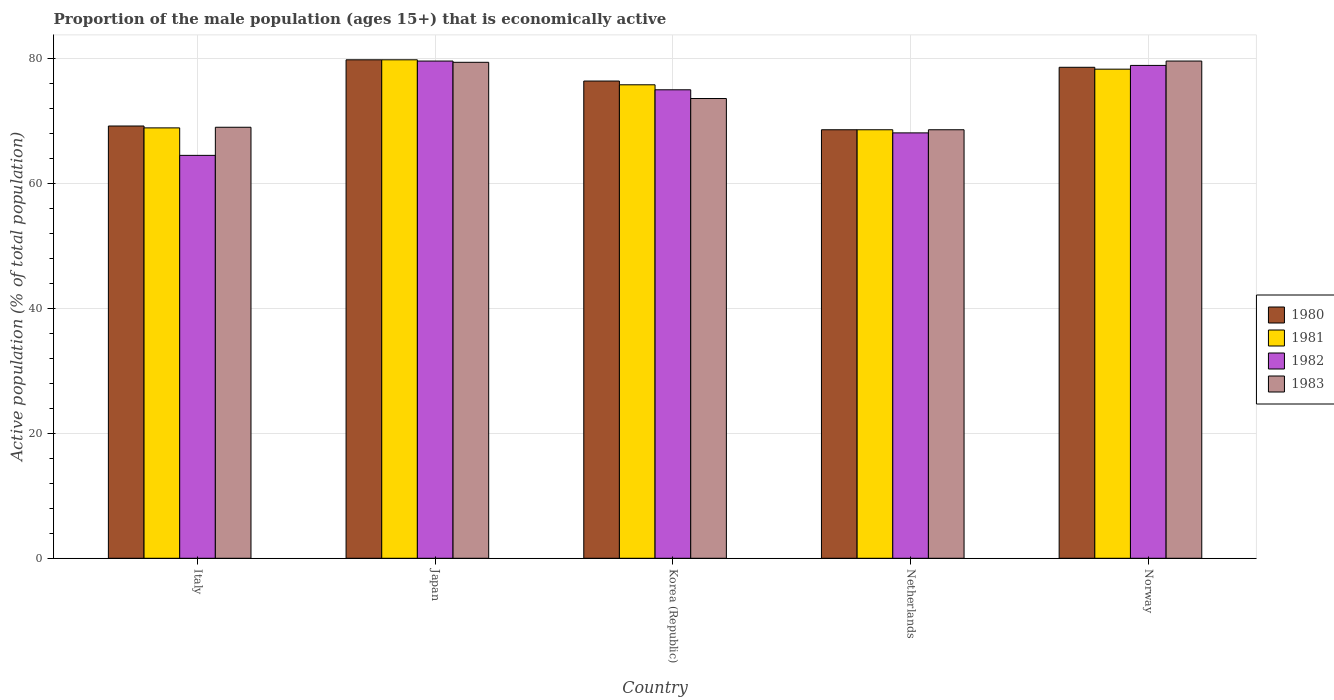Are the number of bars per tick equal to the number of legend labels?
Give a very brief answer. Yes. Are the number of bars on each tick of the X-axis equal?
Provide a succinct answer. Yes. How many bars are there on the 5th tick from the right?
Your answer should be very brief. 4. What is the label of the 5th group of bars from the left?
Give a very brief answer. Norway. In how many cases, is the number of bars for a given country not equal to the number of legend labels?
Provide a short and direct response. 0. What is the proportion of the male population that is economically active in 1981 in Norway?
Offer a terse response. 78.3. Across all countries, what is the maximum proportion of the male population that is economically active in 1983?
Your answer should be compact. 79.6. Across all countries, what is the minimum proportion of the male population that is economically active in 1982?
Keep it short and to the point. 64.5. What is the total proportion of the male population that is economically active in 1983 in the graph?
Ensure brevity in your answer.  370.2. What is the difference between the proportion of the male population that is economically active in 1982 in Italy and that in Norway?
Offer a terse response. -14.4. What is the difference between the proportion of the male population that is economically active in 1983 in Italy and the proportion of the male population that is economically active in 1981 in Japan?
Offer a terse response. -10.8. What is the average proportion of the male population that is economically active in 1983 per country?
Offer a terse response. 74.04. What is the difference between the proportion of the male population that is economically active of/in 1982 and proportion of the male population that is economically active of/in 1980 in Norway?
Offer a terse response. 0.3. What is the ratio of the proportion of the male population that is economically active in 1981 in Italy to that in Netherlands?
Your answer should be very brief. 1. What is the difference between the highest and the second highest proportion of the male population that is economically active in 1981?
Offer a very short reply. -2.5. What is the difference between the highest and the lowest proportion of the male population that is economically active in 1980?
Your answer should be compact. 11.2. In how many countries, is the proportion of the male population that is economically active in 1982 greater than the average proportion of the male population that is economically active in 1982 taken over all countries?
Give a very brief answer. 3. Is the sum of the proportion of the male population that is economically active in 1980 in Japan and Netherlands greater than the maximum proportion of the male population that is economically active in 1982 across all countries?
Make the answer very short. Yes. Is it the case that in every country, the sum of the proportion of the male population that is economically active in 1983 and proportion of the male population that is economically active in 1981 is greater than the sum of proportion of the male population that is economically active in 1982 and proportion of the male population that is economically active in 1980?
Make the answer very short. No. What does the 2nd bar from the right in Japan represents?
Your answer should be compact. 1982. Is it the case that in every country, the sum of the proportion of the male population that is economically active in 1982 and proportion of the male population that is economically active in 1983 is greater than the proportion of the male population that is economically active in 1980?
Keep it short and to the point. Yes. How many bars are there?
Provide a succinct answer. 20. Are all the bars in the graph horizontal?
Provide a succinct answer. No. How many countries are there in the graph?
Keep it short and to the point. 5. How many legend labels are there?
Your answer should be compact. 4. How are the legend labels stacked?
Give a very brief answer. Vertical. What is the title of the graph?
Offer a very short reply. Proportion of the male population (ages 15+) that is economically active. What is the label or title of the X-axis?
Ensure brevity in your answer.  Country. What is the label or title of the Y-axis?
Your answer should be compact. Active population (% of total population). What is the Active population (% of total population) in 1980 in Italy?
Your response must be concise. 69.2. What is the Active population (% of total population) of 1981 in Italy?
Offer a very short reply. 68.9. What is the Active population (% of total population) in 1982 in Italy?
Keep it short and to the point. 64.5. What is the Active population (% of total population) of 1980 in Japan?
Make the answer very short. 79.8. What is the Active population (% of total population) of 1981 in Japan?
Provide a short and direct response. 79.8. What is the Active population (% of total population) of 1982 in Japan?
Make the answer very short. 79.6. What is the Active population (% of total population) of 1983 in Japan?
Ensure brevity in your answer.  79.4. What is the Active population (% of total population) in 1980 in Korea (Republic)?
Make the answer very short. 76.4. What is the Active population (% of total population) in 1981 in Korea (Republic)?
Provide a short and direct response. 75.8. What is the Active population (% of total population) in 1983 in Korea (Republic)?
Give a very brief answer. 73.6. What is the Active population (% of total population) in 1980 in Netherlands?
Give a very brief answer. 68.6. What is the Active population (% of total population) in 1981 in Netherlands?
Your answer should be compact. 68.6. What is the Active population (% of total population) in 1982 in Netherlands?
Offer a terse response. 68.1. What is the Active population (% of total population) of 1983 in Netherlands?
Give a very brief answer. 68.6. What is the Active population (% of total population) of 1980 in Norway?
Ensure brevity in your answer.  78.6. What is the Active population (% of total population) of 1981 in Norway?
Make the answer very short. 78.3. What is the Active population (% of total population) in 1982 in Norway?
Offer a terse response. 78.9. What is the Active population (% of total population) of 1983 in Norway?
Make the answer very short. 79.6. Across all countries, what is the maximum Active population (% of total population) in 1980?
Provide a short and direct response. 79.8. Across all countries, what is the maximum Active population (% of total population) of 1981?
Give a very brief answer. 79.8. Across all countries, what is the maximum Active population (% of total population) of 1982?
Provide a short and direct response. 79.6. Across all countries, what is the maximum Active population (% of total population) of 1983?
Your answer should be very brief. 79.6. Across all countries, what is the minimum Active population (% of total population) in 1980?
Make the answer very short. 68.6. Across all countries, what is the minimum Active population (% of total population) of 1981?
Ensure brevity in your answer.  68.6. Across all countries, what is the minimum Active population (% of total population) in 1982?
Make the answer very short. 64.5. Across all countries, what is the minimum Active population (% of total population) of 1983?
Offer a very short reply. 68.6. What is the total Active population (% of total population) in 1980 in the graph?
Your answer should be very brief. 372.6. What is the total Active population (% of total population) in 1981 in the graph?
Keep it short and to the point. 371.4. What is the total Active population (% of total population) of 1982 in the graph?
Offer a very short reply. 366.1. What is the total Active population (% of total population) of 1983 in the graph?
Make the answer very short. 370.2. What is the difference between the Active population (% of total population) of 1980 in Italy and that in Japan?
Provide a short and direct response. -10.6. What is the difference between the Active population (% of total population) in 1982 in Italy and that in Japan?
Provide a short and direct response. -15.1. What is the difference between the Active population (% of total population) in 1983 in Italy and that in Japan?
Ensure brevity in your answer.  -10.4. What is the difference between the Active population (% of total population) of 1981 in Italy and that in Korea (Republic)?
Your response must be concise. -6.9. What is the difference between the Active population (% of total population) of 1982 in Italy and that in Korea (Republic)?
Your response must be concise. -10.5. What is the difference between the Active population (% of total population) in 1983 in Italy and that in Korea (Republic)?
Offer a very short reply. -4.6. What is the difference between the Active population (% of total population) in 1981 in Italy and that in Netherlands?
Provide a succinct answer. 0.3. What is the difference between the Active population (% of total population) in 1982 in Italy and that in Netherlands?
Your answer should be very brief. -3.6. What is the difference between the Active population (% of total population) of 1980 in Italy and that in Norway?
Your response must be concise. -9.4. What is the difference between the Active population (% of total population) of 1981 in Italy and that in Norway?
Keep it short and to the point. -9.4. What is the difference between the Active population (% of total population) in 1982 in Italy and that in Norway?
Give a very brief answer. -14.4. What is the difference between the Active population (% of total population) of 1983 in Italy and that in Norway?
Your answer should be compact. -10.6. What is the difference between the Active population (% of total population) of 1981 in Japan and that in Korea (Republic)?
Provide a short and direct response. 4. What is the difference between the Active population (% of total population) in 1983 in Japan and that in Korea (Republic)?
Offer a terse response. 5.8. What is the difference between the Active population (% of total population) in 1980 in Japan and that in Netherlands?
Give a very brief answer. 11.2. What is the difference between the Active population (% of total population) in 1982 in Japan and that in Netherlands?
Your response must be concise. 11.5. What is the difference between the Active population (% of total population) in 1981 in Korea (Republic) and that in Netherlands?
Ensure brevity in your answer.  7.2. What is the difference between the Active population (% of total population) in 1981 in Korea (Republic) and that in Norway?
Give a very brief answer. -2.5. What is the difference between the Active population (% of total population) in 1983 in Korea (Republic) and that in Norway?
Offer a very short reply. -6. What is the difference between the Active population (% of total population) in 1980 in Italy and the Active population (% of total population) in 1981 in Japan?
Provide a short and direct response. -10.6. What is the difference between the Active population (% of total population) in 1980 in Italy and the Active population (% of total population) in 1982 in Japan?
Provide a succinct answer. -10.4. What is the difference between the Active population (% of total population) of 1982 in Italy and the Active population (% of total population) of 1983 in Japan?
Keep it short and to the point. -14.9. What is the difference between the Active population (% of total population) in 1980 in Italy and the Active population (% of total population) in 1983 in Korea (Republic)?
Keep it short and to the point. -4.4. What is the difference between the Active population (% of total population) of 1981 in Italy and the Active population (% of total population) of 1983 in Korea (Republic)?
Offer a terse response. -4.7. What is the difference between the Active population (% of total population) of 1980 in Italy and the Active population (% of total population) of 1983 in Netherlands?
Your response must be concise. 0.6. What is the difference between the Active population (% of total population) of 1981 in Italy and the Active population (% of total population) of 1983 in Netherlands?
Provide a short and direct response. 0.3. What is the difference between the Active population (% of total population) of 1982 in Italy and the Active population (% of total population) of 1983 in Netherlands?
Provide a short and direct response. -4.1. What is the difference between the Active population (% of total population) of 1980 in Italy and the Active population (% of total population) of 1981 in Norway?
Provide a short and direct response. -9.1. What is the difference between the Active population (% of total population) in 1981 in Italy and the Active population (% of total population) in 1982 in Norway?
Provide a short and direct response. -10. What is the difference between the Active population (% of total population) of 1982 in Italy and the Active population (% of total population) of 1983 in Norway?
Offer a very short reply. -15.1. What is the difference between the Active population (% of total population) of 1980 in Japan and the Active population (% of total population) of 1981 in Korea (Republic)?
Provide a short and direct response. 4. What is the difference between the Active population (% of total population) of 1980 in Japan and the Active population (% of total population) of 1983 in Korea (Republic)?
Your response must be concise. 6.2. What is the difference between the Active population (% of total population) of 1981 in Japan and the Active population (% of total population) of 1983 in Korea (Republic)?
Give a very brief answer. 6.2. What is the difference between the Active population (% of total population) in 1982 in Japan and the Active population (% of total population) in 1983 in Korea (Republic)?
Make the answer very short. 6. What is the difference between the Active population (% of total population) of 1980 in Japan and the Active population (% of total population) of 1981 in Netherlands?
Keep it short and to the point. 11.2. What is the difference between the Active population (% of total population) in 1980 in Japan and the Active population (% of total population) in 1982 in Netherlands?
Your answer should be very brief. 11.7. What is the difference between the Active population (% of total population) in 1980 in Japan and the Active population (% of total population) in 1983 in Netherlands?
Your answer should be compact. 11.2. What is the difference between the Active population (% of total population) in 1981 in Japan and the Active population (% of total population) in 1983 in Netherlands?
Your answer should be very brief. 11.2. What is the difference between the Active population (% of total population) of 1982 in Japan and the Active population (% of total population) of 1983 in Netherlands?
Make the answer very short. 11. What is the difference between the Active population (% of total population) in 1980 in Japan and the Active population (% of total population) in 1981 in Norway?
Provide a succinct answer. 1.5. What is the difference between the Active population (% of total population) of 1981 in Japan and the Active population (% of total population) of 1983 in Norway?
Keep it short and to the point. 0.2. What is the difference between the Active population (% of total population) in 1982 in Japan and the Active population (% of total population) in 1983 in Norway?
Keep it short and to the point. 0. What is the difference between the Active population (% of total population) in 1980 in Korea (Republic) and the Active population (% of total population) in 1982 in Netherlands?
Offer a terse response. 8.3. What is the difference between the Active population (% of total population) in 1980 in Korea (Republic) and the Active population (% of total population) in 1983 in Netherlands?
Your answer should be very brief. 7.8. What is the difference between the Active population (% of total population) in 1981 in Korea (Republic) and the Active population (% of total population) in 1982 in Netherlands?
Provide a succinct answer. 7.7. What is the difference between the Active population (% of total population) of 1982 in Korea (Republic) and the Active population (% of total population) of 1983 in Netherlands?
Your response must be concise. 6.4. What is the difference between the Active population (% of total population) in 1980 in Korea (Republic) and the Active population (% of total population) in 1982 in Norway?
Your answer should be very brief. -2.5. What is the difference between the Active population (% of total population) in 1980 in Korea (Republic) and the Active population (% of total population) in 1983 in Norway?
Offer a very short reply. -3.2. What is the difference between the Active population (% of total population) of 1981 in Korea (Republic) and the Active population (% of total population) of 1982 in Norway?
Ensure brevity in your answer.  -3.1. What is the difference between the Active population (% of total population) of 1982 in Korea (Republic) and the Active population (% of total population) of 1983 in Norway?
Your response must be concise. -4.6. What is the difference between the Active population (% of total population) in 1980 in Netherlands and the Active population (% of total population) in 1981 in Norway?
Offer a very short reply. -9.7. What is the difference between the Active population (% of total population) of 1980 in Netherlands and the Active population (% of total population) of 1982 in Norway?
Ensure brevity in your answer.  -10.3. What is the difference between the Active population (% of total population) of 1980 in Netherlands and the Active population (% of total population) of 1983 in Norway?
Offer a terse response. -11. What is the difference between the Active population (% of total population) in 1981 in Netherlands and the Active population (% of total population) in 1983 in Norway?
Keep it short and to the point. -11. What is the difference between the Active population (% of total population) in 1982 in Netherlands and the Active population (% of total population) in 1983 in Norway?
Your response must be concise. -11.5. What is the average Active population (% of total population) of 1980 per country?
Make the answer very short. 74.52. What is the average Active population (% of total population) of 1981 per country?
Provide a succinct answer. 74.28. What is the average Active population (% of total population) in 1982 per country?
Provide a succinct answer. 73.22. What is the average Active population (% of total population) in 1983 per country?
Offer a terse response. 74.04. What is the difference between the Active population (% of total population) in 1980 and Active population (% of total population) in 1981 in Italy?
Ensure brevity in your answer.  0.3. What is the difference between the Active population (% of total population) of 1980 and Active population (% of total population) of 1982 in Italy?
Keep it short and to the point. 4.7. What is the difference between the Active population (% of total population) in 1981 and Active population (% of total population) in 1982 in Italy?
Give a very brief answer. 4.4. What is the difference between the Active population (% of total population) in 1981 and Active population (% of total population) in 1983 in Italy?
Ensure brevity in your answer.  -0.1. What is the difference between the Active population (% of total population) in 1980 and Active population (% of total population) in 1981 in Japan?
Offer a very short reply. 0. What is the difference between the Active population (% of total population) of 1980 and Active population (% of total population) of 1983 in Japan?
Offer a very short reply. 0.4. What is the difference between the Active population (% of total population) of 1982 and Active population (% of total population) of 1983 in Japan?
Offer a terse response. 0.2. What is the difference between the Active population (% of total population) in 1980 and Active population (% of total population) in 1981 in Korea (Republic)?
Provide a succinct answer. 0.6. What is the difference between the Active population (% of total population) of 1980 and Active population (% of total population) of 1983 in Korea (Republic)?
Your answer should be compact. 2.8. What is the difference between the Active population (% of total population) in 1980 and Active population (% of total population) in 1982 in Netherlands?
Provide a succinct answer. 0.5. What is the difference between the Active population (% of total population) of 1980 and Active population (% of total population) of 1983 in Netherlands?
Offer a very short reply. 0. What is the difference between the Active population (% of total population) of 1982 and Active population (% of total population) of 1983 in Netherlands?
Provide a short and direct response. -0.5. What is the difference between the Active population (% of total population) in 1980 and Active population (% of total population) in 1981 in Norway?
Your answer should be compact. 0.3. What is the difference between the Active population (% of total population) of 1980 and Active population (% of total population) of 1982 in Norway?
Ensure brevity in your answer.  -0.3. What is the difference between the Active population (% of total population) of 1981 and Active population (% of total population) of 1982 in Norway?
Ensure brevity in your answer.  -0.6. What is the difference between the Active population (% of total population) in 1982 and Active population (% of total population) in 1983 in Norway?
Your answer should be compact. -0.7. What is the ratio of the Active population (% of total population) in 1980 in Italy to that in Japan?
Give a very brief answer. 0.87. What is the ratio of the Active population (% of total population) in 1981 in Italy to that in Japan?
Keep it short and to the point. 0.86. What is the ratio of the Active population (% of total population) in 1982 in Italy to that in Japan?
Offer a terse response. 0.81. What is the ratio of the Active population (% of total population) of 1983 in Italy to that in Japan?
Offer a very short reply. 0.87. What is the ratio of the Active population (% of total population) of 1980 in Italy to that in Korea (Republic)?
Give a very brief answer. 0.91. What is the ratio of the Active population (% of total population) of 1981 in Italy to that in Korea (Republic)?
Your answer should be very brief. 0.91. What is the ratio of the Active population (% of total population) in 1982 in Italy to that in Korea (Republic)?
Offer a terse response. 0.86. What is the ratio of the Active population (% of total population) of 1983 in Italy to that in Korea (Republic)?
Offer a terse response. 0.94. What is the ratio of the Active population (% of total population) in 1980 in Italy to that in Netherlands?
Your answer should be compact. 1.01. What is the ratio of the Active population (% of total population) in 1981 in Italy to that in Netherlands?
Offer a terse response. 1. What is the ratio of the Active population (% of total population) of 1982 in Italy to that in Netherlands?
Provide a short and direct response. 0.95. What is the ratio of the Active population (% of total population) of 1983 in Italy to that in Netherlands?
Keep it short and to the point. 1.01. What is the ratio of the Active population (% of total population) of 1980 in Italy to that in Norway?
Provide a short and direct response. 0.88. What is the ratio of the Active population (% of total population) of 1981 in Italy to that in Norway?
Provide a short and direct response. 0.88. What is the ratio of the Active population (% of total population) of 1982 in Italy to that in Norway?
Ensure brevity in your answer.  0.82. What is the ratio of the Active population (% of total population) of 1983 in Italy to that in Norway?
Provide a succinct answer. 0.87. What is the ratio of the Active population (% of total population) of 1980 in Japan to that in Korea (Republic)?
Provide a succinct answer. 1.04. What is the ratio of the Active population (% of total population) in 1981 in Japan to that in Korea (Republic)?
Your answer should be very brief. 1.05. What is the ratio of the Active population (% of total population) in 1982 in Japan to that in Korea (Republic)?
Offer a terse response. 1.06. What is the ratio of the Active population (% of total population) of 1983 in Japan to that in Korea (Republic)?
Provide a succinct answer. 1.08. What is the ratio of the Active population (% of total population) of 1980 in Japan to that in Netherlands?
Your response must be concise. 1.16. What is the ratio of the Active population (% of total population) of 1981 in Japan to that in Netherlands?
Ensure brevity in your answer.  1.16. What is the ratio of the Active population (% of total population) in 1982 in Japan to that in Netherlands?
Provide a short and direct response. 1.17. What is the ratio of the Active population (% of total population) in 1983 in Japan to that in Netherlands?
Provide a succinct answer. 1.16. What is the ratio of the Active population (% of total population) of 1980 in Japan to that in Norway?
Ensure brevity in your answer.  1.02. What is the ratio of the Active population (% of total population) in 1981 in Japan to that in Norway?
Provide a succinct answer. 1.02. What is the ratio of the Active population (% of total population) in 1982 in Japan to that in Norway?
Provide a succinct answer. 1.01. What is the ratio of the Active population (% of total population) in 1983 in Japan to that in Norway?
Provide a succinct answer. 1. What is the ratio of the Active population (% of total population) in 1980 in Korea (Republic) to that in Netherlands?
Make the answer very short. 1.11. What is the ratio of the Active population (% of total population) in 1981 in Korea (Republic) to that in Netherlands?
Provide a succinct answer. 1.1. What is the ratio of the Active population (% of total population) of 1982 in Korea (Republic) to that in Netherlands?
Offer a terse response. 1.1. What is the ratio of the Active population (% of total population) of 1983 in Korea (Republic) to that in Netherlands?
Your answer should be compact. 1.07. What is the ratio of the Active population (% of total population) in 1981 in Korea (Republic) to that in Norway?
Ensure brevity in your answer.  0.97. What is the ratio of the Active population (% of total population) in 1982 in Korea (Republic) to that in Norway?
Provide a succinct answer. 0.95. What is the ratio of the Active population (% of total population) of 1983 in Korea (Republic) to that in Norway?
Provide a succinct answer. 0.92. What is the ratio of the Active population (% of total population) in 1980 in Netherlands to that in Norway?
Provide a short and direct response. 0.87. What is the ratio of the Active population (% of total population) of 1981 in Netherlands to that in Norway?
Keep it short and to the point. 0.88. What is the ratio of the Active population (% of total population) of 1982 in Netherlands to that in Norway?
Keep it short and to the point. 0.86. What is the ratio of the Active population (% of total population) in 1983 in Netherlands to that in Norway?
Your answer should be very brief. 0.86. What is the difference between the highest and the second highest Active population (% of total population) in 1982?
Ensure brevity in your answer.  0.7. What is the difference between the highest and the second highest Active population (% of total population) of 1983?
Make the answer very short. 0.2. What is the difference between the highest and the lowest Active population (% of total population) in 1981?
Your answer should be very brief. 11.2. What is the difference between the highest and the lowest Active population (% of total population) of 1982?
Ensure brevity in your answer.  15.1. 